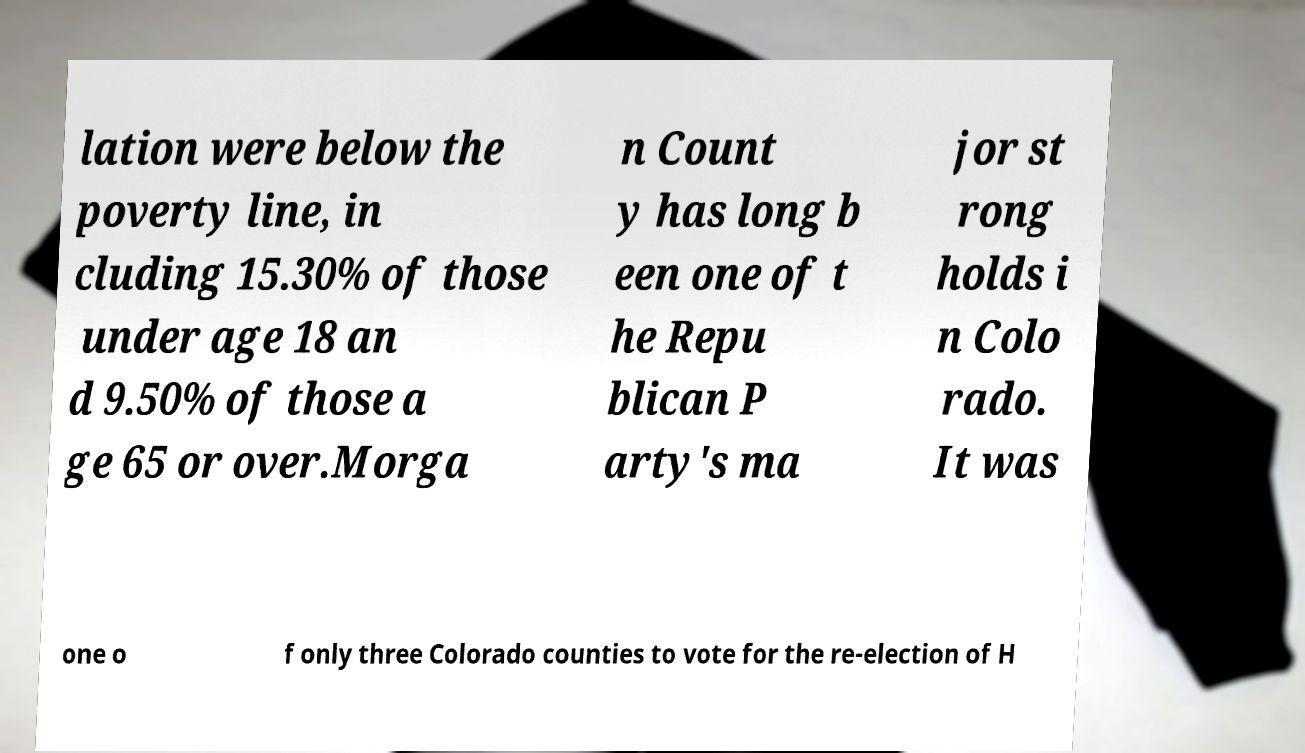Can you read and provide the text displayed in the image?This photo seems to have some interesting text. Can you extract and type it out for me? lation were below the poverty line, in cluding 15.30% of those under age 18 an d 9.50% of those a ge 65 or over.Morga n Count y has long b een one of t he Repu blican P arty's ma jor st rong holds i n Colo rado. It was one o f only three Colorado counties to vote for the re-election of H 